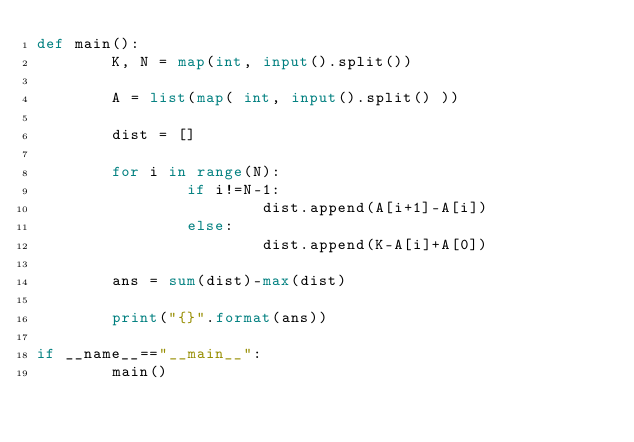Convert code to text. <code><loc_0><loc_0><loc_500><loc_500><_Python_>def main():
        K, N = map(int, input().split())

        A = list(map( int, input().split() ))

        dist = []

        for i in range(N):
                if i!=N-1:
                        dist.append(A[i+1]-A[i])
                else:
                        dist.append(K-A[i]+A[0])

        ans = sum(dist)-max(dist)

        print("{}".format(ans))

if __name__=="__main__":
        main()</code> 